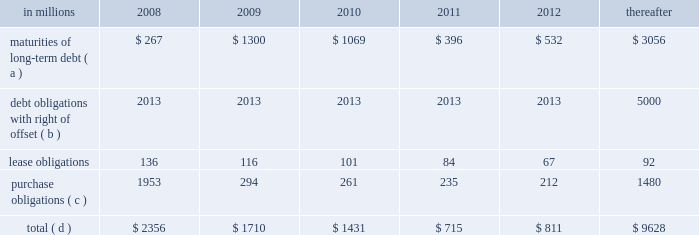Exchanged installment notes totaling approximately $ 4.8 billion and approximately $ 400 million of inter- national paper promissory notes for interests in enti- ties formed to monetize the notes .
International paper determined that it was not the primary benefi- ciary of these entities , and therefore should not consolidate its investments in these entities .
During 2006 , these entities acquired an additional $ 4.8 bil- lion of international paper debt securities for cash , resulting in a total of approximately $ 5.2 billion of international paper debt obligations held by these entities at december 31 , 2006 .
Since international paper has , and intends to affect , a legal right to offset its obligations under these debt instruments with its investments in the entities , international paper has offset $ 5.0 billion of interest in the entities against $ 5.0 billion of international paper debt obligations held by the entities as of december 31 , 2007 .
International paper also holds variable interests in two financing entities that were used to monetize long-term notes received from sales of forestlands in 2002 and 2001 .
See note 8 of the notes to consolidated financial statements in item 8 .
Financial statements and supplementary data for a further discussion of these transactions .
Capital resources outlook for 2008 international paper expects to be able to meet pro- jected capital expenditures , service existing debt and meet working capital and dividend requirements during 2008 through current cash balances and cash from operations , supplemented as required by its various existing credit facilities .
International paper has approximately $ 2.5 billion of committed bank credit agreements , which management believes is adequate to cover expected operating cash flow variability during our industry 2019s economic cycles .
The agreements generally provide for interest rates at a floating rate index plus a pre-determined margin dependent upon international paper 2019s credit rating .
The agreements include a $ 1.5 billion fully commit- ted revolving bank credit agreement that expires in march 2011 and has a facility fee of 0.10% ( 0.10 % ) payable quarterly .
These agreements also include up to $ 1.0 billion of available commercial paper-based financ- ings under a receivables securitization program that expires in october 2009 with a facility fee of 0.10% ( 0.10 % ) .
At december 31 , 2007 , there were no borrowings under either the bank credit agreements or receiv- ables securitization program .
The company will continue to rely upon debt and capital markets for the majority of any necessary long-term funding not provided by operating cash flows .
Funding decisions will be guided by our capi- tal structure planning objectives .
The primary goals of the company 2019s capital structure planning are to maximize financial flexibility and preserve liquidity while reducing interest expense .
The majority of international paper 2019s debt is accessed through global public capital markets where we have a wide base of investors .
The company was in compliance with all its debt covenants at december 31 , 2007 .
Principal financial covenants include maintenance of a minimum net worth , defined as the sum of common stock , paid-in capital and retained earnings , less treasury stock , plus any goodwill impairment charges , of $ 9 billion ; and a maximum total debt to capital ratio , defined as total debt divided by total debt plus net worth , of 60% ( 60 % ) .
Maintaining an investment grade credit rating is an important element of international paper 2019s financing strategy .
At december 31 , 2007 , the company held long-term credit ratings of bbb ( stable outlook ) and baa3 ( stable outlook ) by standard & poor 2019s ( s&p ) and moody 2019s investor services ( moody 2019s ) , respectively .
The company currently has short-term credit ratings by s&p and moody 2019s of a-2 and p-3 , respectively .
Contractual obligations for future payments under existing debt and lease commitments and purchase obligations at december 31 , 2007 , were as follows : in millions 2008 2009 2010 2011 2012 thereafter maturities of long-term debt ( a ) $ 267 $ 1300 $ 1069 $ 396 $ 532 $ 3056 debt obligations with right of offset ( b ) 2013 2013 2013 2013 2013 5000 .
( a ) total debt includes scheduled principal payments only .
( b ) represents debt obligations borrowed from non-consolidated variable interest entities for which international paper has , and intends to affect , a legal right to offset these obligations with investments held in the entities .
Accordingly , in its con- solidated balance sheet at december 31 , 2007 , international paper has offset approximately $ 5.0 billion of interests in the entities against this $ 5.0 billion of debt obligations held by the entities ( see note 8 in the accompanying consolidated financial statements ) .
( c ) includes $ 2.1 billion relating to fiber supply agreements entered into at the time of the transformation plan forestland sales .
( d ) not included in the above table are unrecognized tax benefits of approximately $ 280 million. .
What percentage of contractual obligations for future payments under existing debt and lease commitments and purchase obligations at december 31 , 2007 for the year of 2008 are due to maturities of long-term debt? 
Computations: (267 / 2356)
Answer: 0.11333. Exchanged installment notes totaling approximately $ 4.8 billion and approximately $ 400 million of inter- national paper promissory notes for interests in enti- ties formed to monetize the notes .
International paper determined that it was not the primary benefi- ciary of these entities , and therefore should not consolidate its investments in these entities .
During 2006 , these entities acquired an additional $ 4.8 bil- lion of international paper debt securities for cash , resulting in a total of approximately $ 5.2 billion of international paper debt obligations held by these entities at december 31 , 2006 .
Since international paper has , and intends to affect , a legal right to offset its obligations under these debt instruments with its investments in the entities , international paper has offset $ 5.0 billion of interest in the entities against $ 5.0 billion of international paper debt obligations held by the entities as of december 31 , 2007 .
International paper also holds variable interests in two financing entities that were used to monetize long-term notes received from sales of forestlands in 2002 and 2001 .
See note 8 of the notes to consolidated financial statements in item 8 .
Financial statements and supplementary data for a further discussion of these transactions .
Capital resources outlook for 2008 international paper expects to be able to meet pro- jected capital expenditures , service existing debt and meet working capital and dividend requirements during 2008 through current cash balances and cash from operations , supplemented as required by its various existing credit facilities .
International paper has approximately $ 2.5 billion of committed bank credit agreements , which management believes is adequate to cover expected operating cash flow variability during our industry 2019s economic cycles .
The agreements generally provide for interest rates at a floating rate index plus a pre-determined margin dependent upon international paper 2019s credit rating .
The agreements include a $ 1.5 billion fully commit- ted revolving bank credit agreement that expires in march 2011 and has a facility fee of 0.10% ( 0.10 % ) payable quarterly .
These agreements also include up to $ 1.0 billion of available commercial paper-based financ- ings under a receivables securitization program that expires in october 2009 with a facility fee of 0.10% ( 0.10 % ) .
At december 31 , 2007 , there were no borrowings under either the bank credit agreements or receiv- ables securitization program .
The company will continue to rely upon debt and capital markets for the majority of any necessary long-term funding not provided by operating cash flows .
Funding decisions will be guided by our capi- tal structure planning objectives .
The primary goals of the company 2019s capital structure planning are to maximize financial flexibility and preserve liquidity while reducing interest expense .
The majority of international paper 2019s debt is accessed through global public capital markets where we have a wide base of investors .
The company was in compliance with all its debt covenants at december 31 , 2007 .
Principal financial covenants include maintenance of a minimum net worth , defined as the sum of common stock , paid-in capital and retained earnings , less treasury stock , plus any goodwill impairment charges , of $ 9 billion ; and a maximum total debt to capital ratio , defined as total debt divided by total debt plus net worth , of 60% ( 60 % ) .
Maintaining an investment grade credit rating is an important element of international paper 2019s financing strategy .
At december 31 , 2007 , the company held long-term credit ratings of bbb ( stable outlook ) and baa3 ( stable outlook ) by standard & poor 2019s ( s&p ) and moody 2019s investor services ( moody 2019s ) , respectively .
The company currently has short-term credit ratings by s&p and moody 2019s of a-2 and p-3 , respectively .
Contractual obligations for future payments under existing debt and lease commitments and purchase obligations at december 31 , 2007 , were as follows : in millions 2008 2009 2010 2011 2012 thereafter maturities of long-term debt ( a ) $ 267 $ 1300 $ 1069 $ 396 $ 532 $ 3056 debt obligations with right of offset ( b ) 2013 2013 2013 2013 2013 5000 .
( a ) total debt includes scheduled principal payments only .
( b ) represents debt obligations borrowed from non-consolidated variable interest entities for which international paper has , and intends to affect , a legal right to offset these obligations with investments held in the entities .
Accordingly , in its con- solidated balance sheet at december 31 , 2007 , international paper has offset approximately $ 5.0 billion of interests in the entities against this $ 5.0 billion of debt obligations held by the entities ( see note 8 in the accompanying consolidated financial statements ) .
( c ) includes $ 2.1 billion relating to fiber supply agreements entered into at the time of the transformation plan forestland sales .
( d ) not included in the above table are unrecognized tax benefits of approximately $ 280 million. .
In 2009 what was the percent of the maturities of long-term debt of the total contractual obligations for future payments? 
Computations: (1300 / 1710)
Answer: 0.76023. 